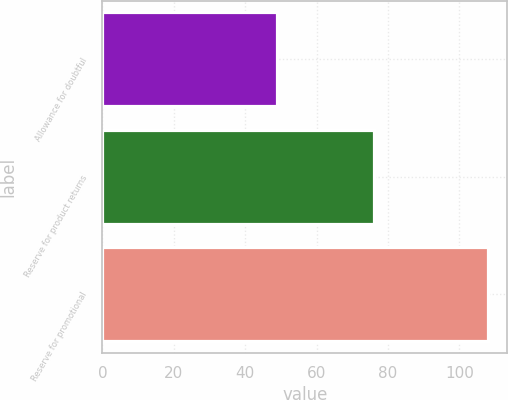Convert chart. <chart><loc_0><loc_0><loc_500><loc_500><bar_chart><fcel>Allowance for doubtful<fcel>Reserve for product returns<fcel>Reserve for promotional<nl><fcel>49<fcel>76<fcel>108<nl></chart> 